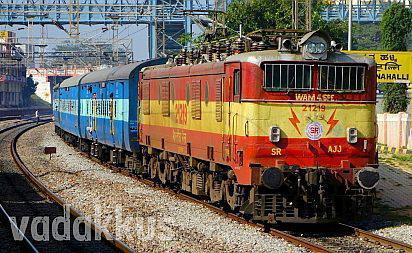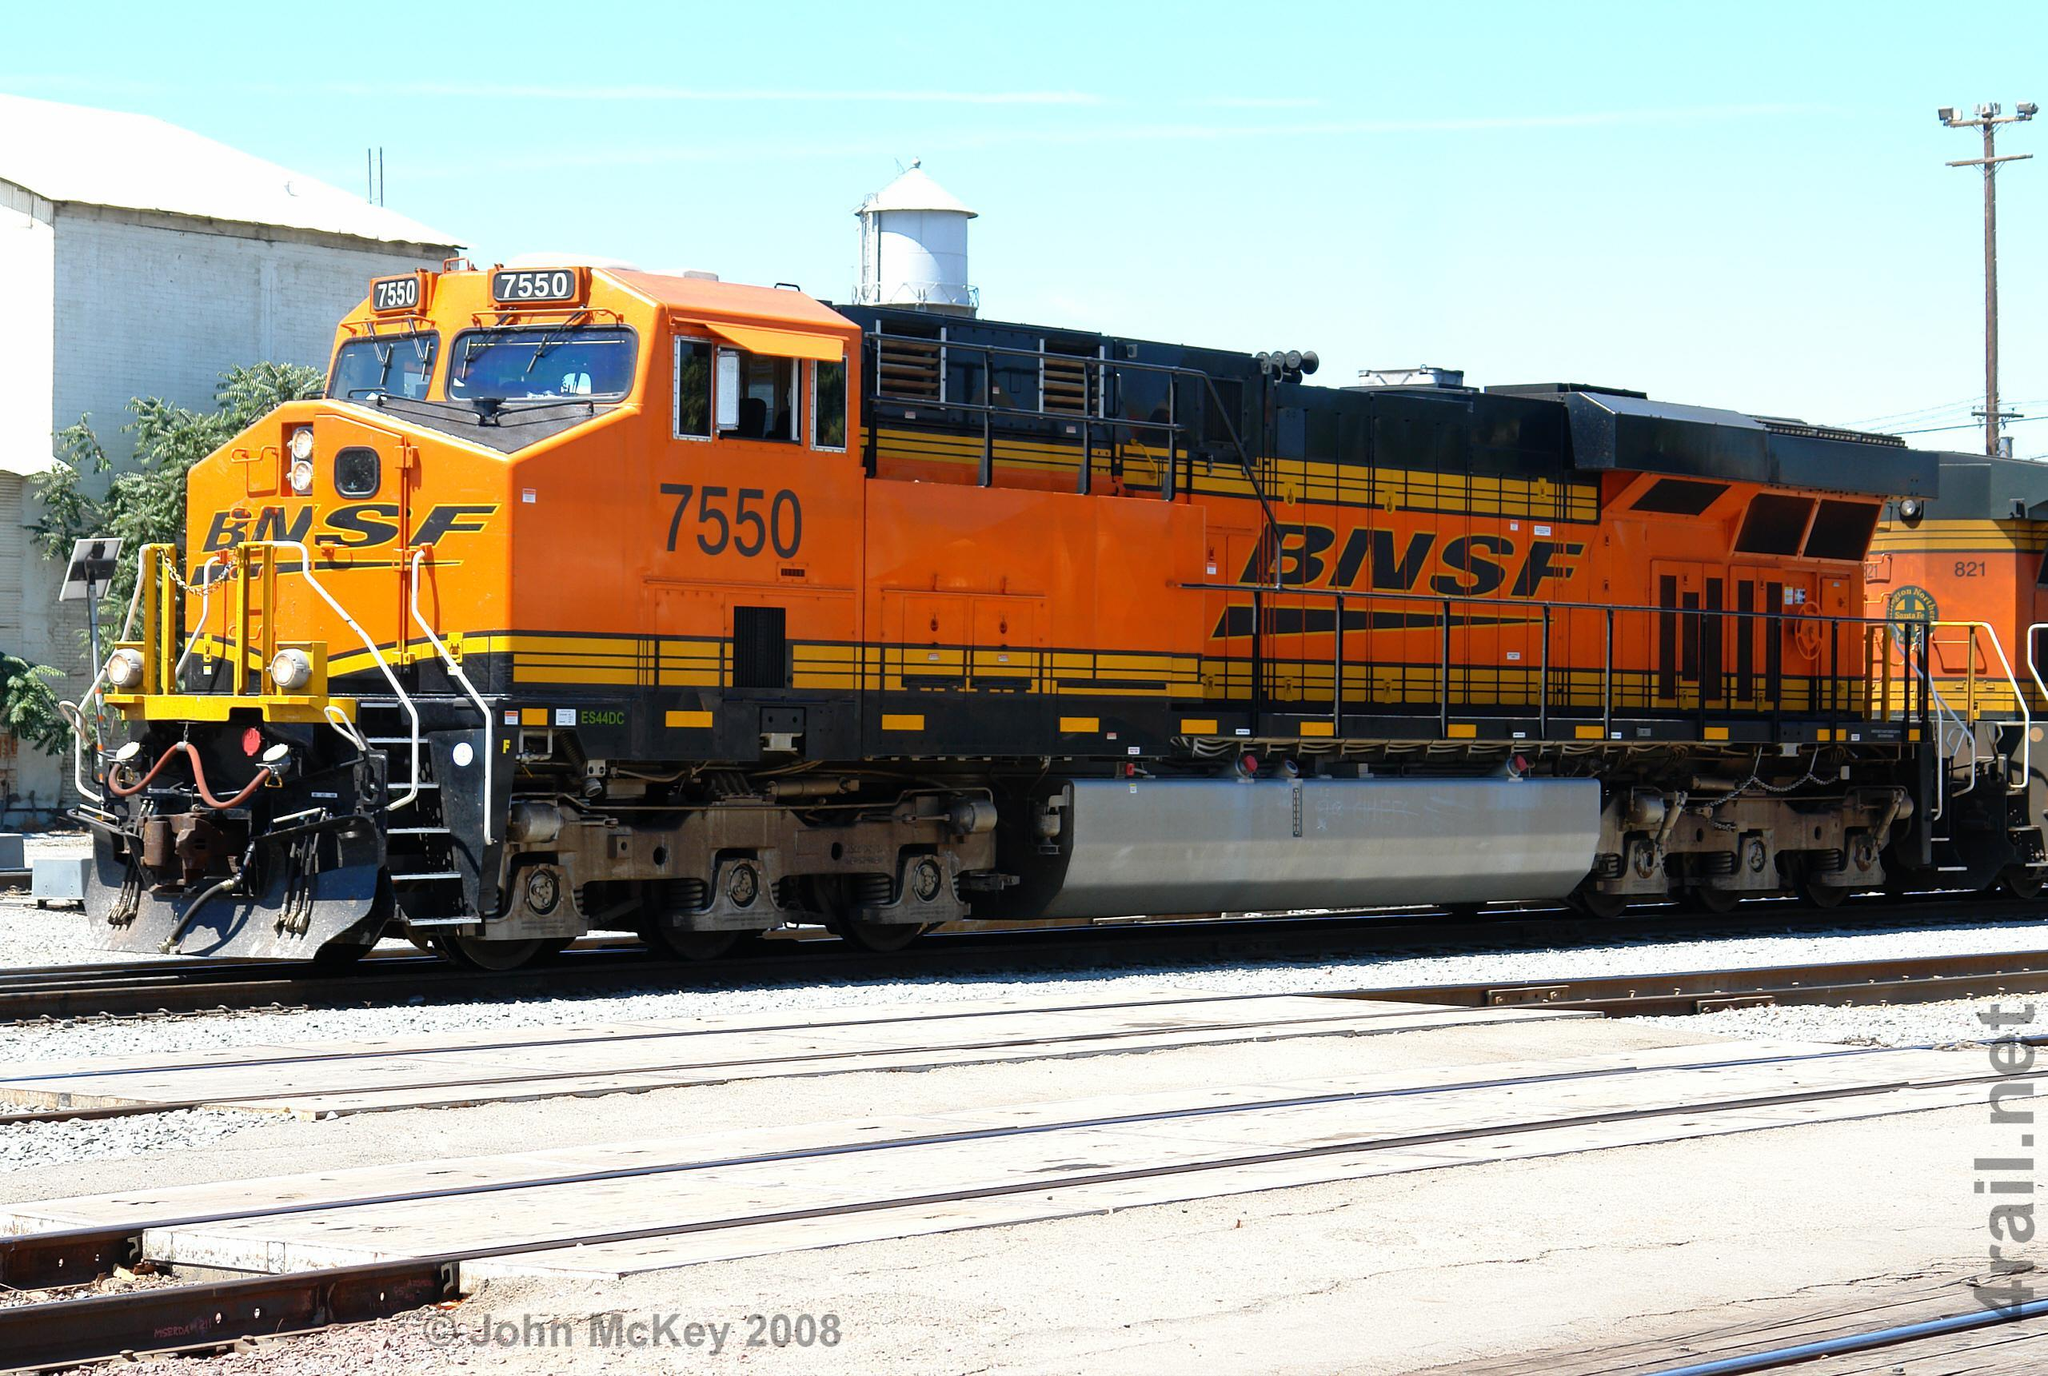The first image is the image on the left, the second image is the image on the right. Analyze the images presented: Is the assertion "The trains in the left and right images appear to be headed toward each other, so they would collide." valid? Answer yes or no. Yes. 